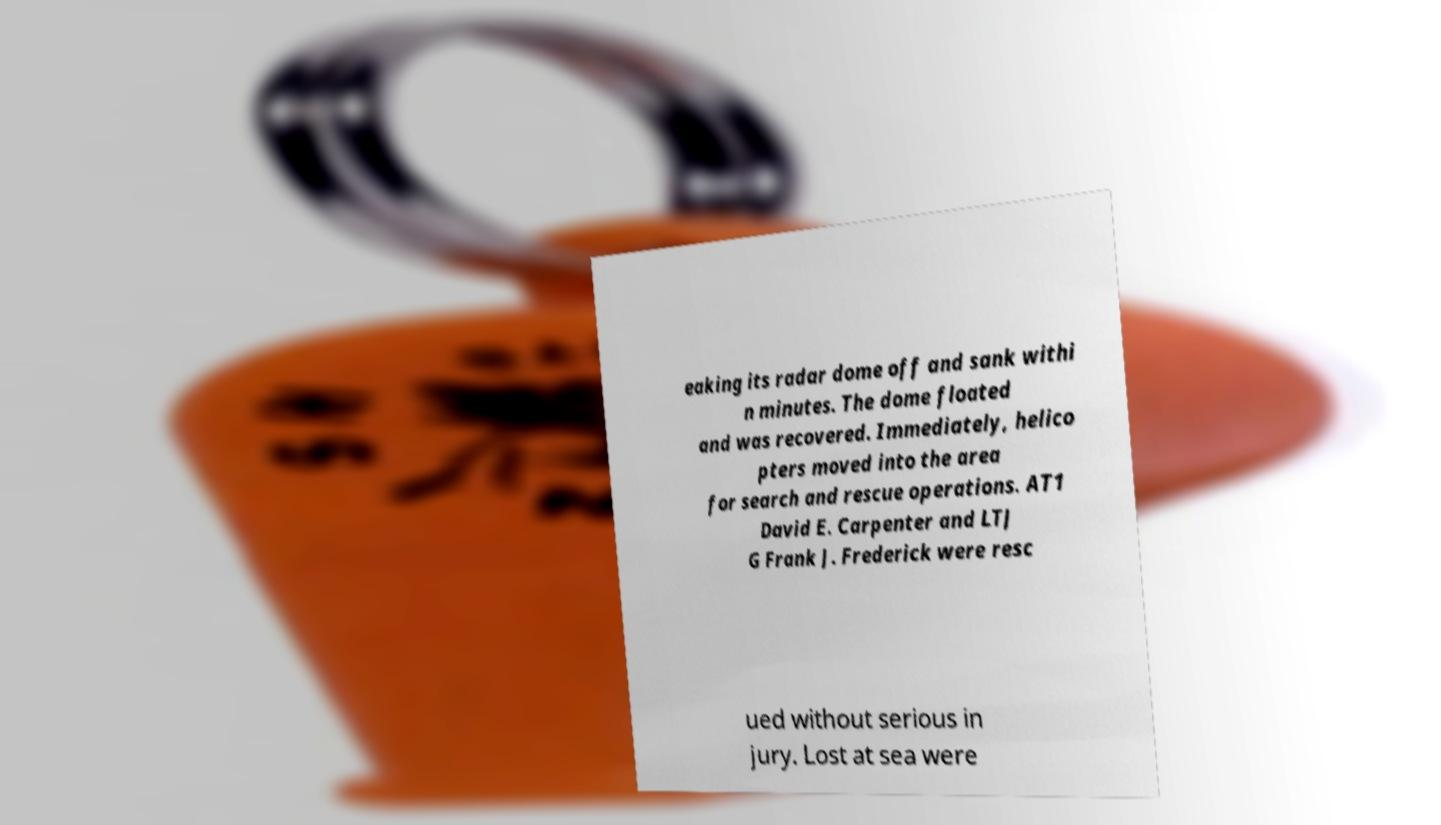Please identify and transcribe the text found in this image. eaking its radar dome off and sank withi n minutes. The dome floated and was recovered. Immediately, helico pters moved into the area for search and rescue operations. AT1 David E. Carpenter and LTJ G Frank J. Frederick were resc ued without serious in jury. Lost at sea were 